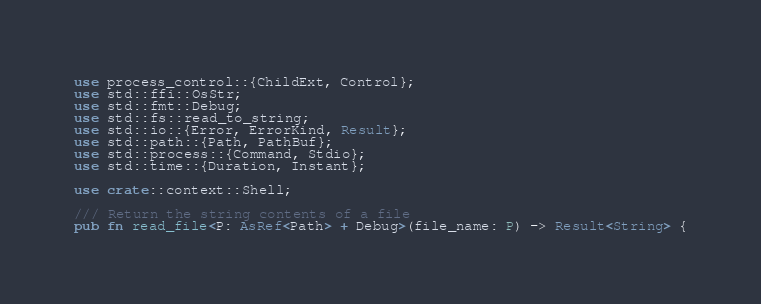Convert code to text. <code><loc_0><loc_0><loc_500><loc_500><_Rust_>use process_control::{ChildExt, Control};
use std::ffi::OsStr;
use std::fmt::Debug;
use std::fs::read_to_string;
use std::io::{Error, ErrorKind, Result};
use std::path::{Path, PathBuf};
use std::process::{Command, Stdio};
use std::time::{Duration, Instant};

use crate::context::Shell;

/// Return the string contents of a file
pub fn read_file<P: AsRef<Path> + Debug>(file_name: P) -> Result<String> {</code> 